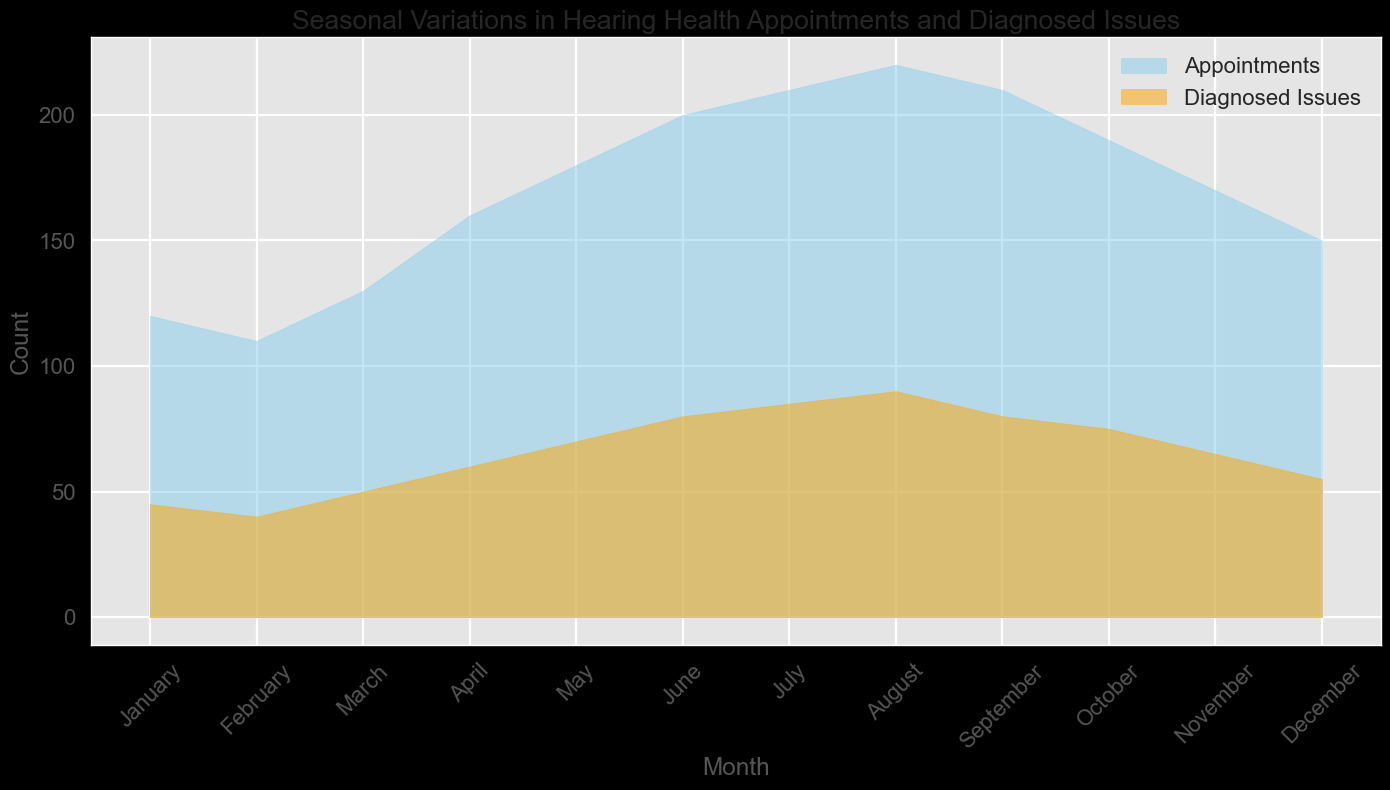Which month has the highest number of appointments? January to December are listed on the x-axis, and the fill extends highest for the 'Appointments' category in August.
Answer: August How does the number of diagnosed issues in April compare to that in October? Referring to the 'Diagnosed Issues' fill, April and October heights can be compared. Diagnosed issues count is higher in April than in October.
Answer: Higher Which months have the same number of diagnosed issues? Checking the visual heights, July and August have diagnosed issues that appear to be at the same height.
Answer: July and August What is the total number of appointments in the first quarter? Summing up the values for January, February, and March: 120 + 110 + 130 = 360
Answer: 360 What's the difference between the highest number of appointments and the number of appointments in December? The highest number of appointments occurs in August (220). Subtracting the December appointments: 220 - 150 = 70
Answer: 70 During which month is the gap between appointments and diagnosed issues highest? Visually, the widest gap between the fills for 'Appointments' and 'Diagnosed Issues' occurs in August.
Answer: August What is the trend of appointments from June to September? The heights of the 'Appointments' fill rise from June (200) to August (220), then it decreases in September (210).
Answer: Increase then decrease Calculate the average number of diagnosed issues over the year. Summing up diagnosed issues from each month (45 + 40 + 50 + 60 + 70 + 80 + 85 + 90 + 80 + 75 + 65 + 55 = 795) and dividing by 12 months: 795 / 12 ≈ 66.25
Answer: 66.25 Which month shows the smallest number of appointments? The shortest fill for 'Appointments' is in February (110).
Answer: February What is the variance in the number of diagnosed issues between March and April? Subtracting the number of diagnosed issues in March from April's: 60 - 50 = 10
Answer: 10 